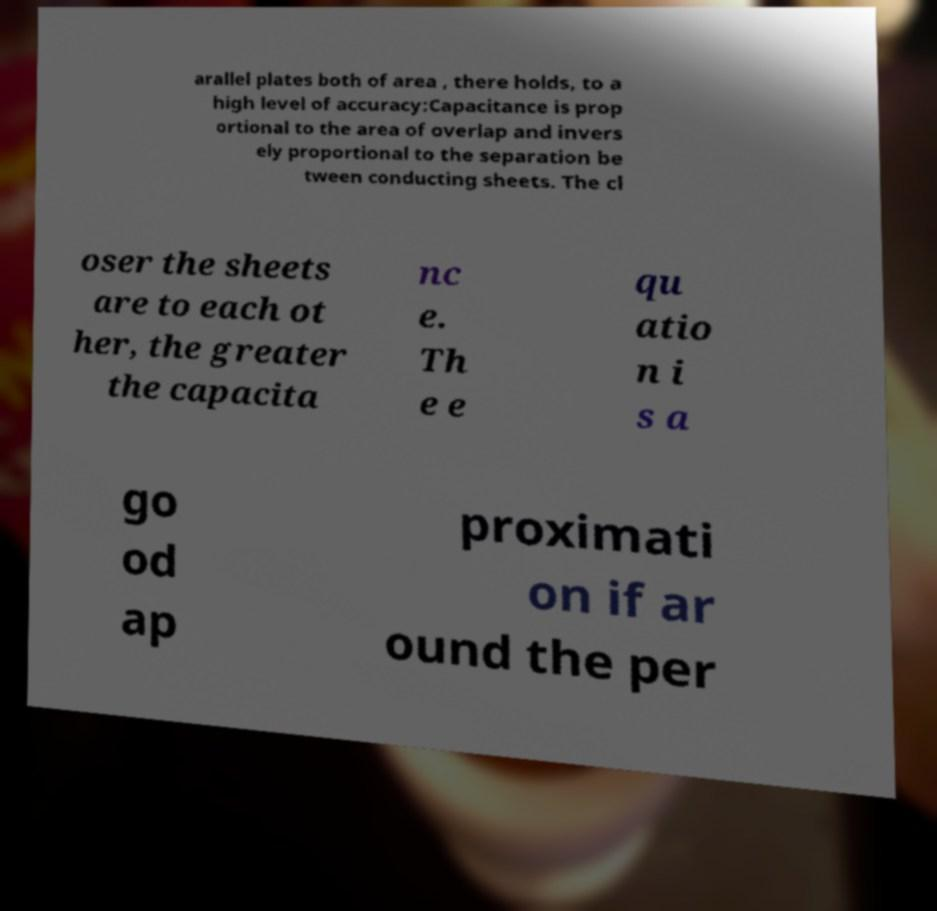Please identify and transcribe the text found in this image. arallel plates both of area , there holds, to a high level of accuracy:Capacitance is prop ortional to the area of overlap and invers ely proportional to the separation be tween conducting sheets. The cl oser the sheets are to each ot her, the greater the capacita nc e. Th e e qu atio n i s a go od ap proximati on if ar ound the per 